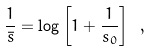<formula> <loc_0><loc_0><loc_500><loc_500>\frac { 1 } { \bar { s } } = \log \left [ 1 + \frac { 1 } { s _ { 0 } } \right ] \ ,</formula> 